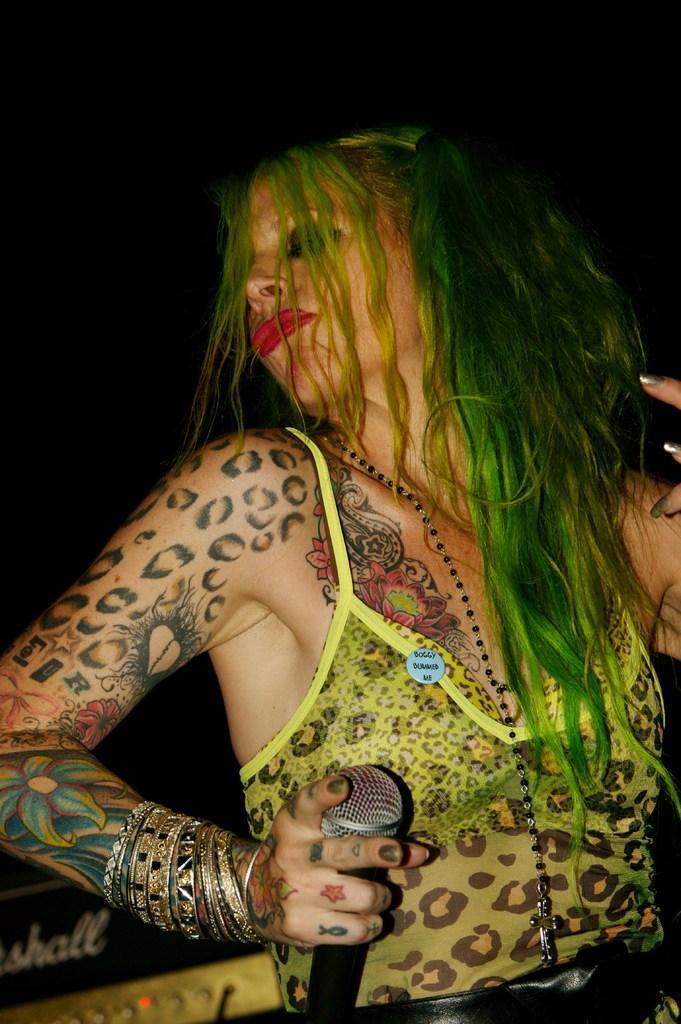In one or two sentences, can you explain what this image depicts? A woman is holding microphone in her hand. 